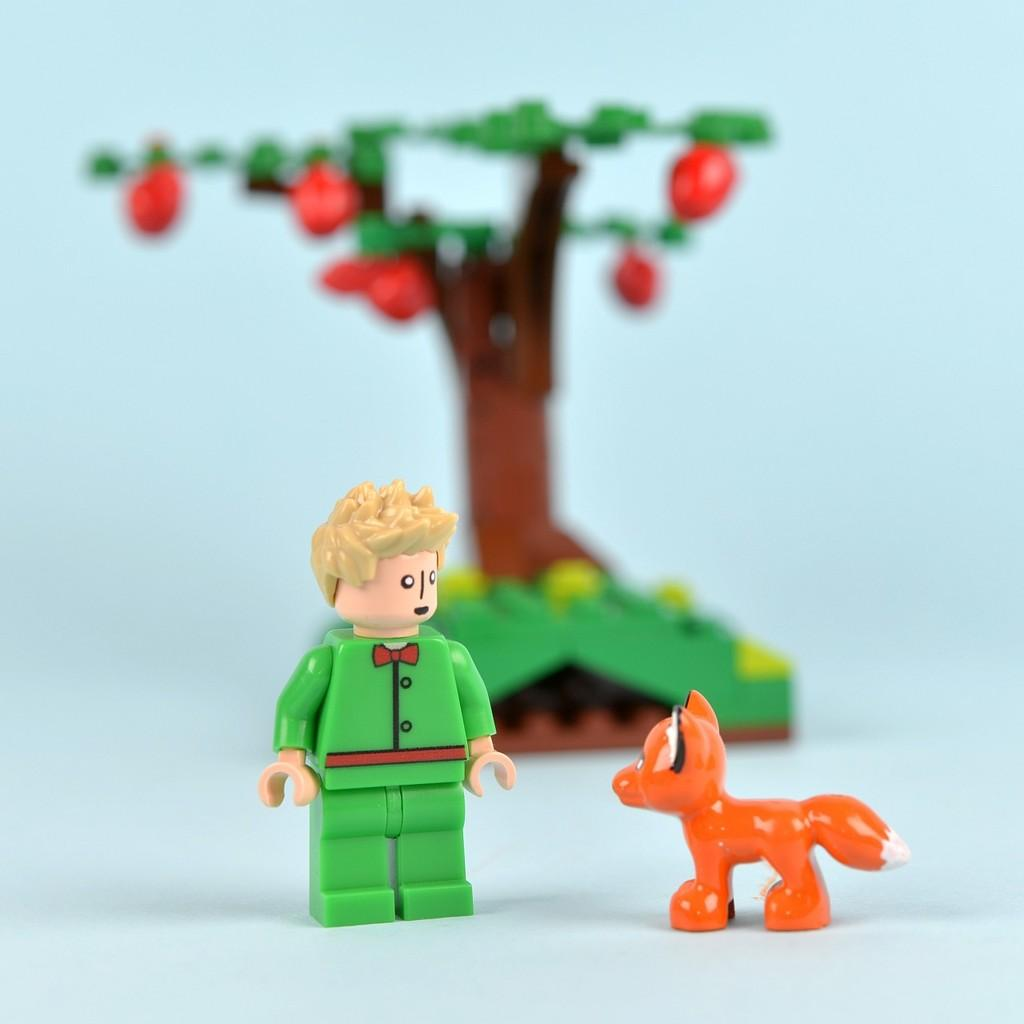What type of objects are in the image? There are miniatures in the image. What can be seen in the background of the image? There is a toy tree in the background of the image. What is located in the middle of the image? There is a toy person and a toy animal in the middle of the image. On what surface are the toy person and toy animal placed? The toy person and toy animal are on a surface. What type of horn can be seen on the toy animal in the image? There is no horn present on the toy animal in the image. 